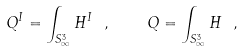<formula> <loc_0><loc_0><loc_500><loc_500>Q ^ { I } = \int _ { S ^ { 3 } _ { \infty } } H ^ { I } \ , \quad Q = \int _ { S ^ { 3 } _ { \infty } } H \ ,</formula> 